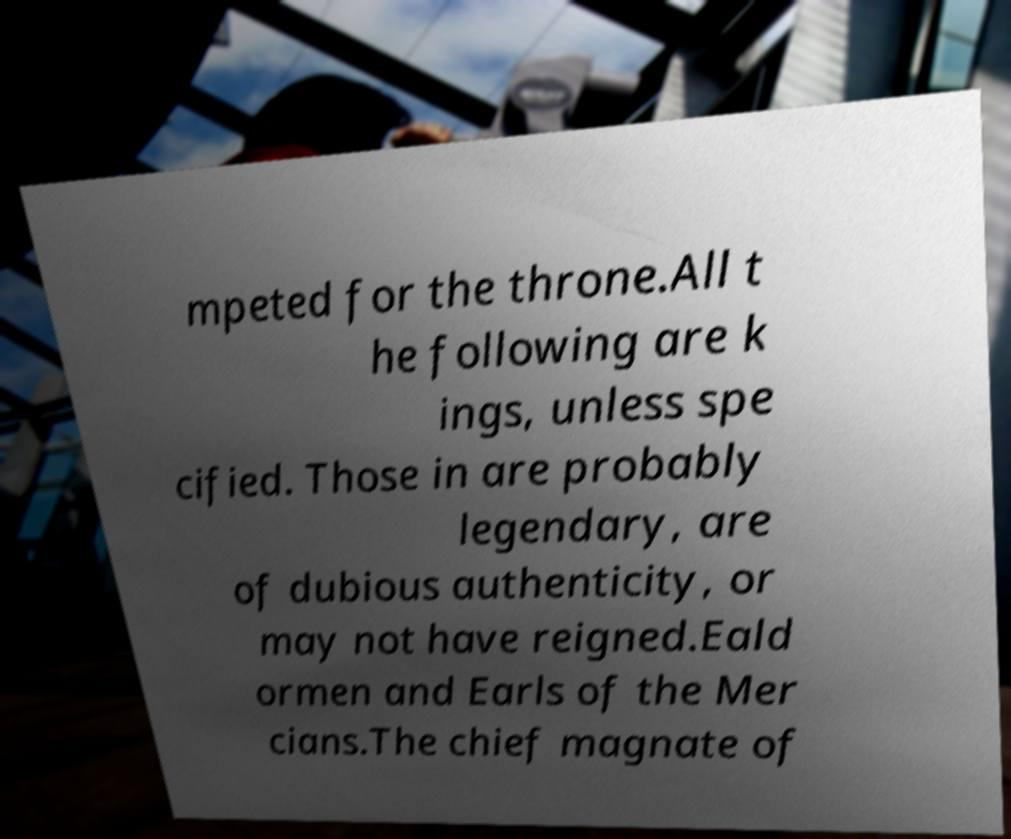Can you read and provide the text displayed in the image?This photo seems to have some interesting text. Can you extract and type it out for me? mpeted for the throne.All t he following are k ings, unless spe cified. Those in are probably legendary, are of dubious authenticity, or may not have reigned.Eald ormen and Earls of the Mer cians.The chief magnate of 